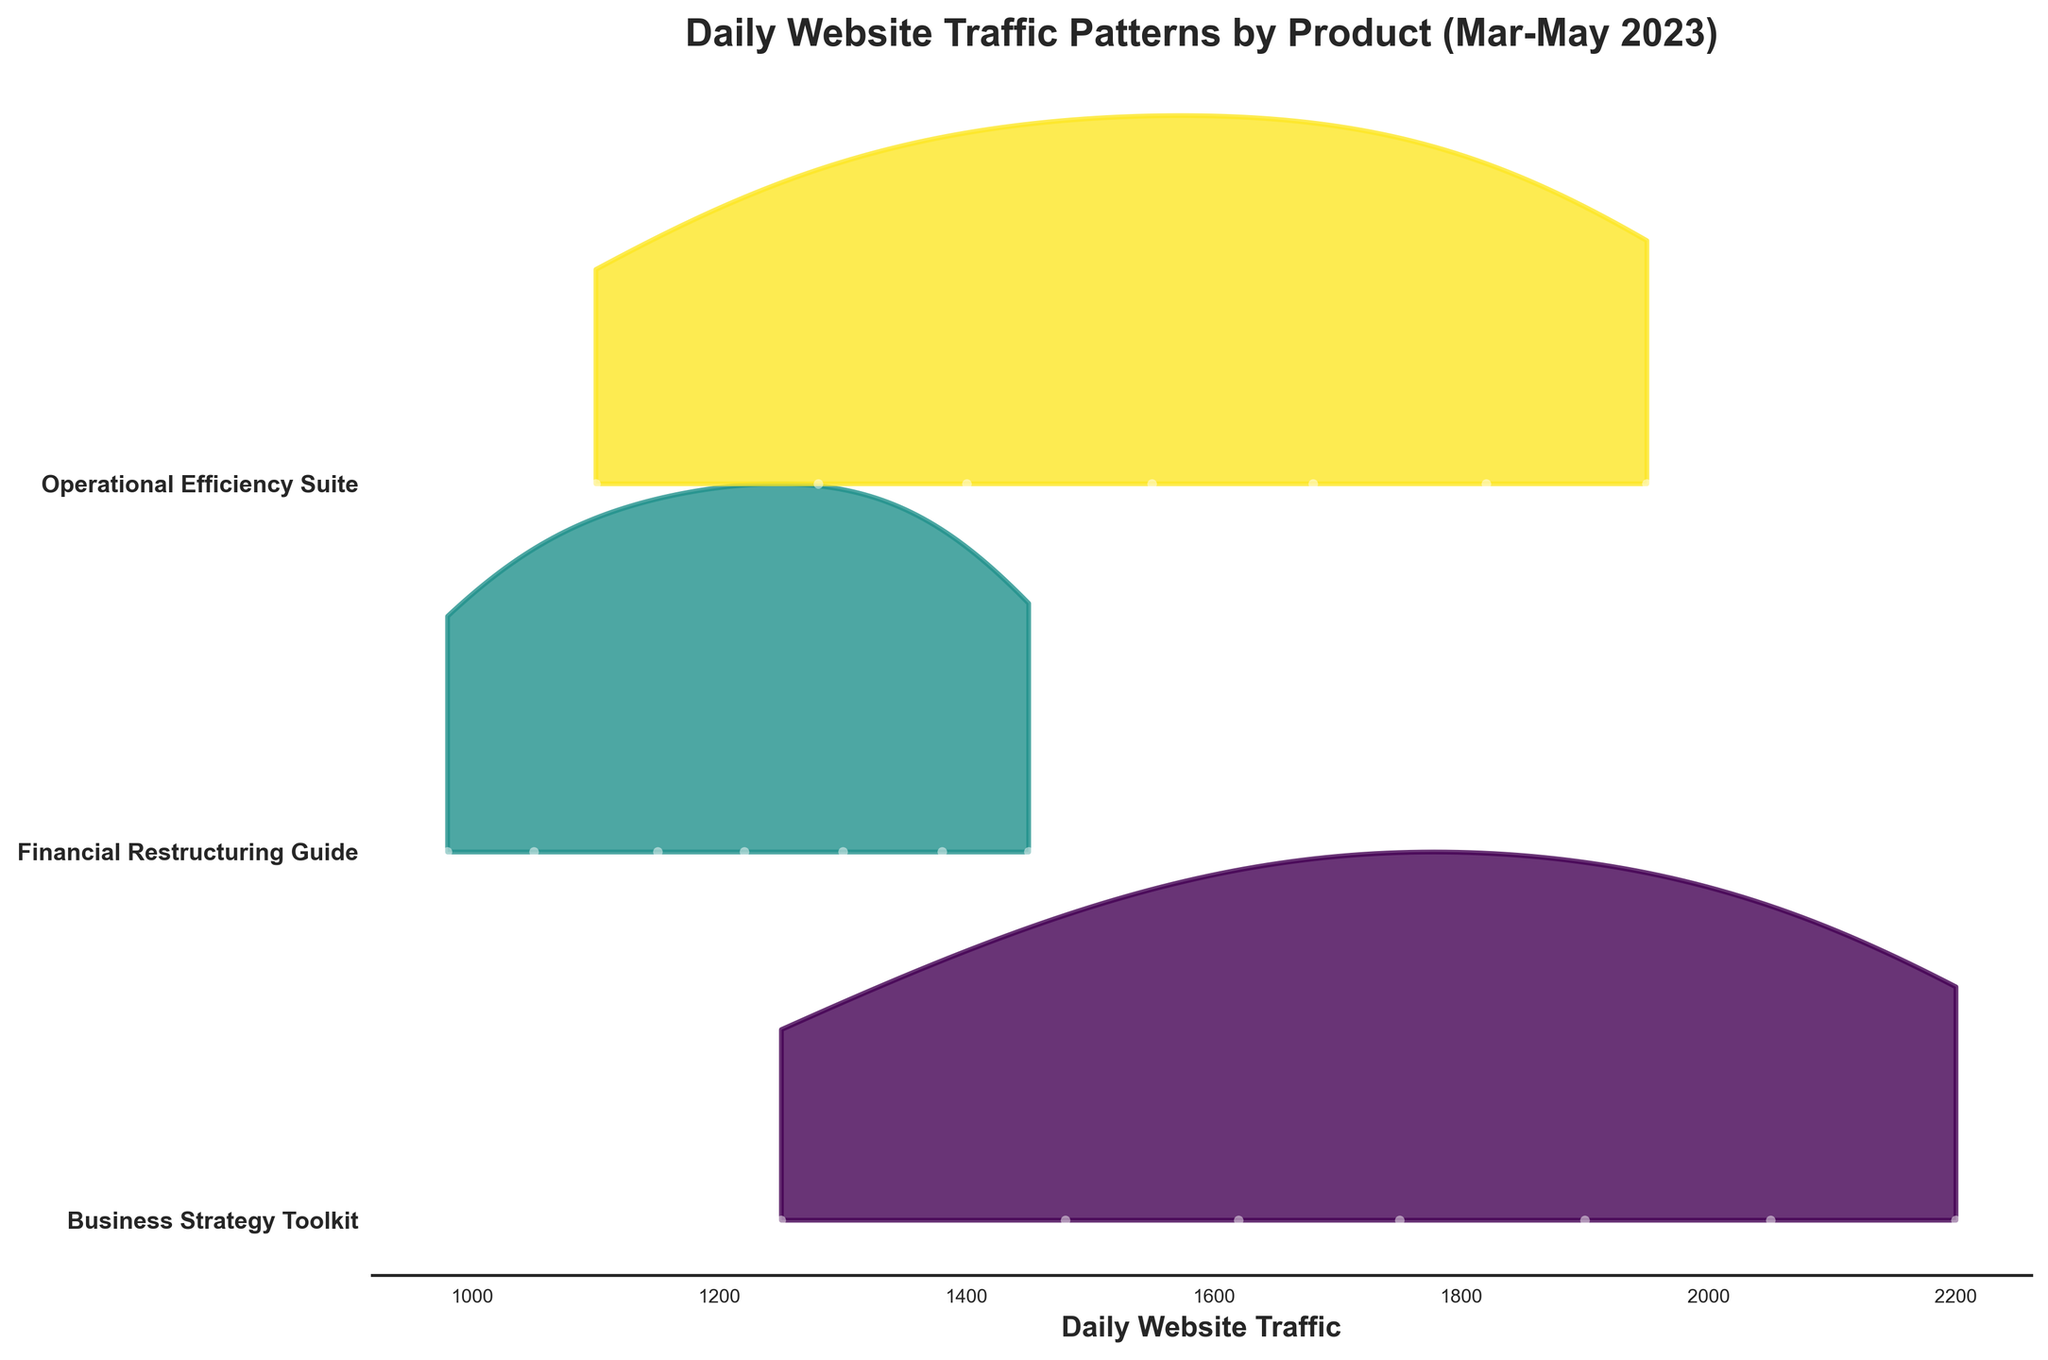What is the title of the figure? The title can be found at the top of the figure. It typically describes the overall purpose or main point of the figure.
Answer: Daily Website Traffic Patterns by Product (Mar-May 2023) What does the x-axis represent? The x-axis in the figure displays the range of daily website traffic values. This axis helps to show the traffic volume for the company's product pages.
Answer: Daily Website Traffic Which product had the highest website traffic at the end of May 2023? To determine this, look for the highest data point on the rightmost side of the plot representing May 30, 2023. Identify which product is itemized on the y-axis corresponding to this highest traffic value.
Answer: Business Strategy Toolkit How many unique products are displayed in this figure? The number of unique products can be identified by counting the number of distinct labels on the y-axis. Each label corresponds to a different product.
Answer: 3 What is the traffic range for the Financial Restructuring Guide over the 3-month period? The traffic range can be identified by finding the minimum and maximum traffic values for the Financial Restructuring Guide across all plotted data points in the figure.
Answer: 980 to 1450 Compare the traffic of the Operational Efficiency Suite and Financial Restructuring Guide on April 15, 2023. Which product had higher traffic on this date? Look for the data points on April 15, 2023, for both products. Compare their heights to determine which product had higher traffic.
Answer: Operational Efficiency Suite Which product shows a consistent increase in traffic over the 3-month period? Observe the trend lines and data points of each product from March to May. Look for the product whose traffic values continually rise without falling in any given month.
Answer: Business Strategy Toolkit Between the Business Strategy Toolkit and Operational Efficiency Suite, which product had more website traffic on March 15, 2023? Identify the data points for both products on March 15, 2023. Compare their respective heights to determine which product had more traffic that day.
Answer: Business Strategy Toolkit What is the median traffic value for the Operational Efficiency Suite? To find the median value, identify all traffic values for the Operational Efficiency Suite. Arrange them in ascending order, and locate the middle value in this sequence. For this dataset: (1100, 1280, 1400, 1550, 1680, 1820, 1950) - the median would be the 4th value.
Answer: 1550 Which month had the highest peak in website traffic for the Business Strategy Toolkit? Identify the highest peak value for the Business Strategy Toolkit. Then, determine in which of the three months this peak occurred by referencing the date corresponding to this value.
Answer: May 